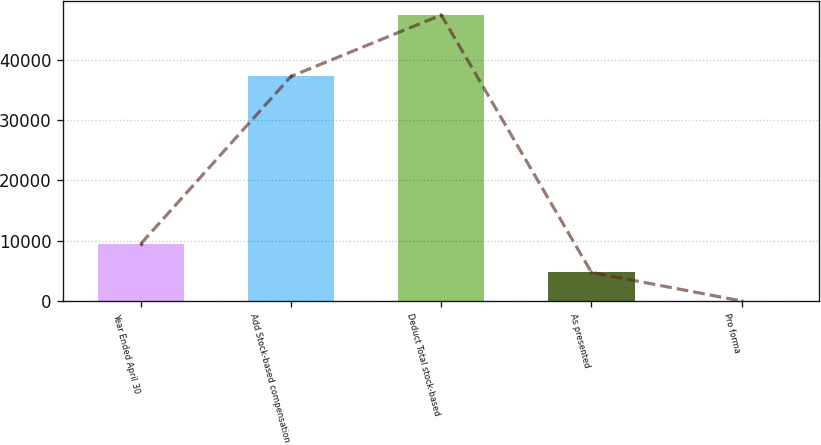Convert chart. <chart><loc_0><loc_0><loc_500><loc_500><bar_chart><fcel>Year Ended April 30<fcel>Add Stock-based compensation<fcel>Deduct Total stock-based<fcel>As presented<fcel>Pro forma<nl><fcel>9486.76<fcel>37254<fcel>47428<fcel>4744.11<fcel>1.46<nl></chart> 